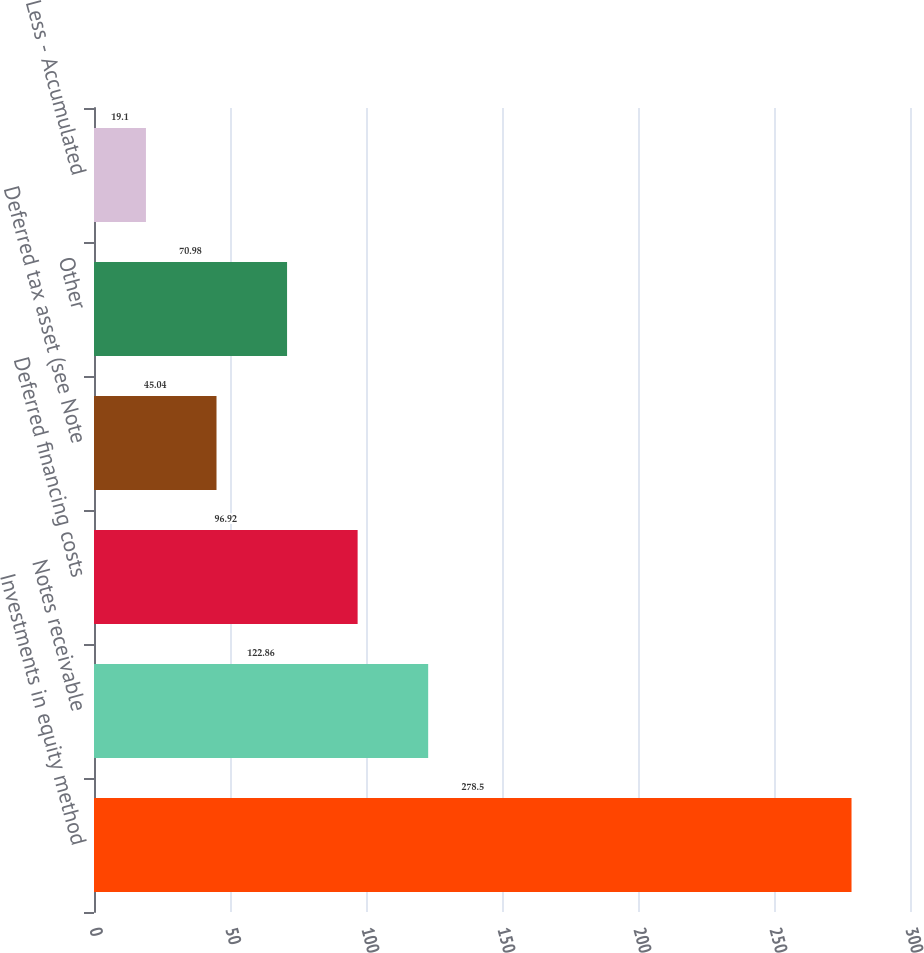<chart> <loc_0><loc_0><loc_500><loc_500><bar_chart><fcel>Investments in equity method<fcel>Notes receivable<fcel>Deferred financing costs<fcel>Deferred tax asset (see Note<fcel>Other<fcel>Less - Accumulated<nl><fcel>278.5<fcel>122.86<fcel>96.92<fcel>45.04<fcel>70.98<fcel>19.1<nl></chart> 